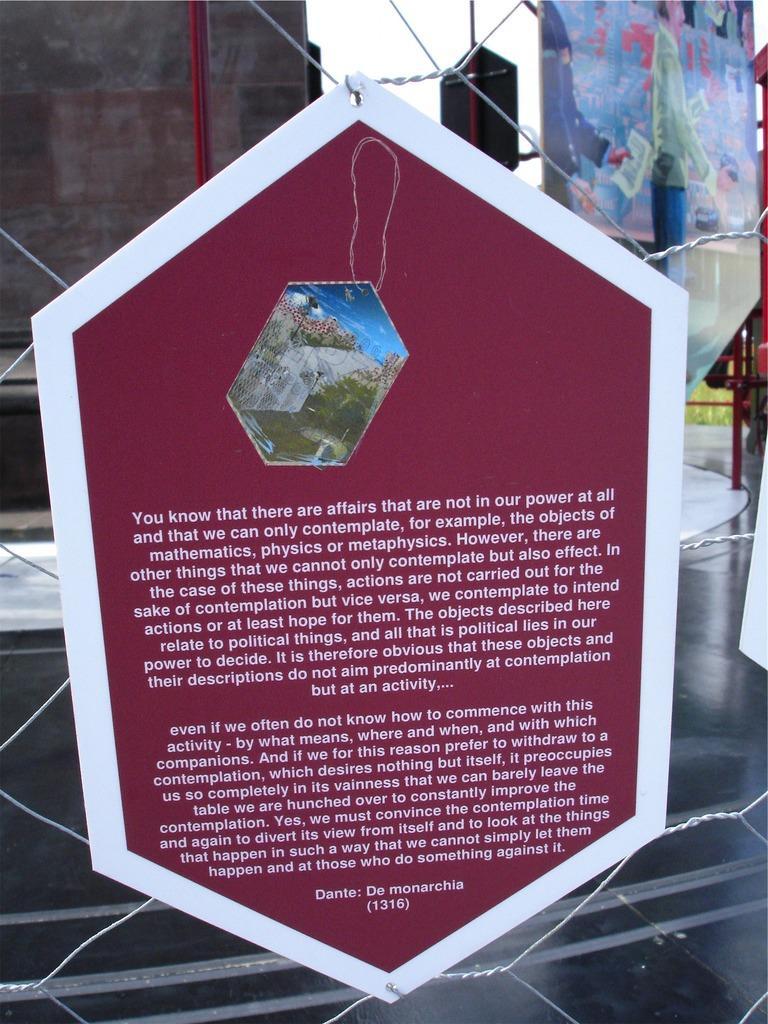Describe this image in one or two sentences. There is a wire mesh. On that there is a poster with something written on that. In the back there is a road and a wall. 